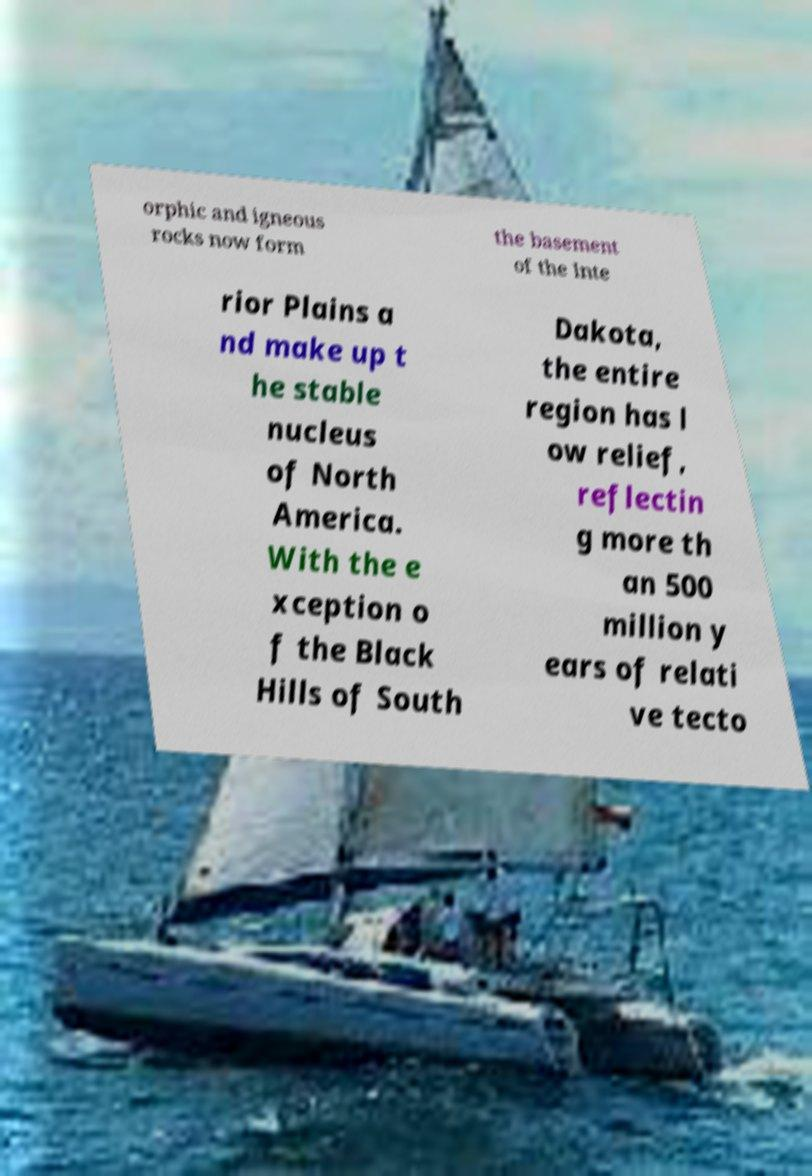For documentation purposes, I need the text within this image transcribed. Could you provide that? orphic and igneous rocks now form the basement of the Inte rior Plains a nd make up t he stable nucleus of North America. With the e xception o f the Black Hills of South Dakota, the entire region has l ow relief, reflectin g more th an 500 million y ears of relati ve tecto 